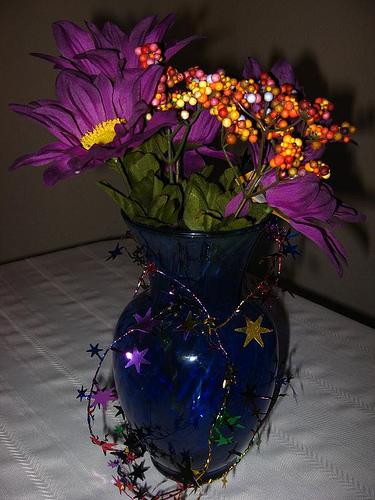What type of a flower is this?
Write a very short answer. Lily. What is draped around the vase?
Be succinct. Stars. Is this a decoration?
Give a very brief answer. Yes. What is the vase sitting on?
Quick response, please. Table. 